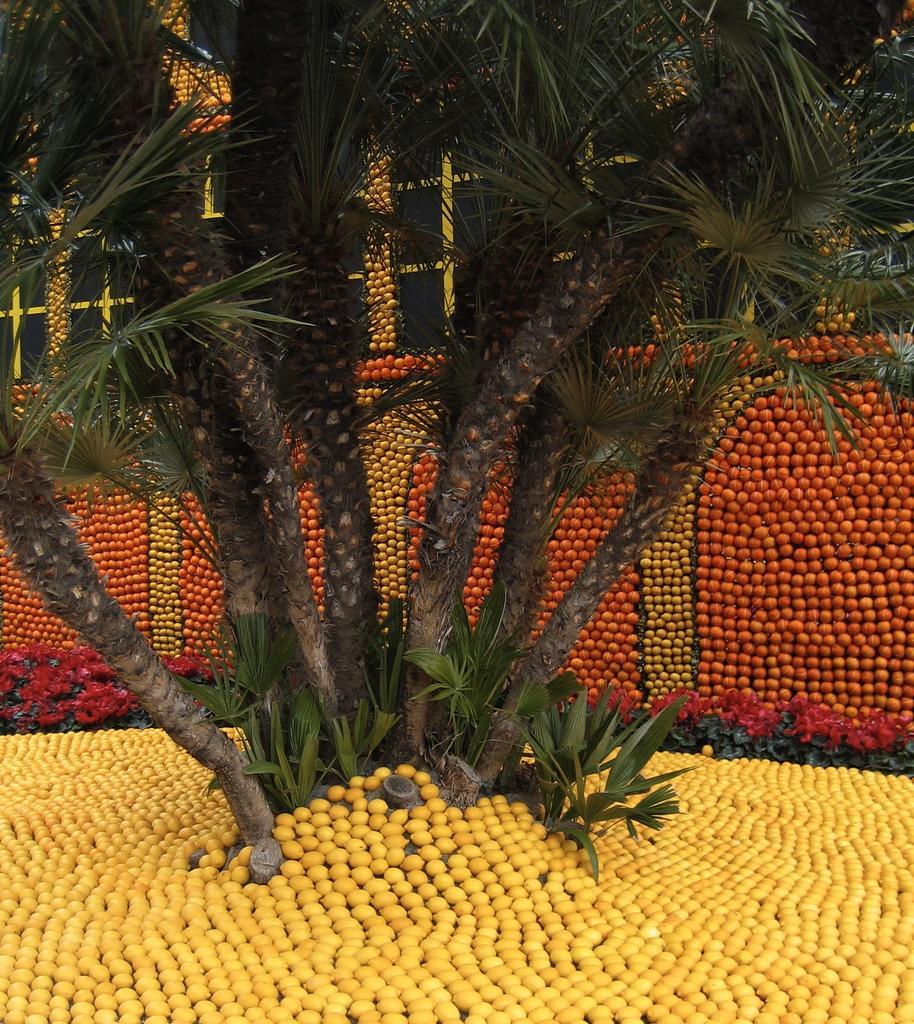In one or two sentences, can you explain what this image depicts? There is group of trees and plants on the ground. Around them, there are yellow color flowers arranged on the ground. In the background, there is a wall. Which is decorated with different colors fruits. And building which is having glass windows and decorated with fruits. 